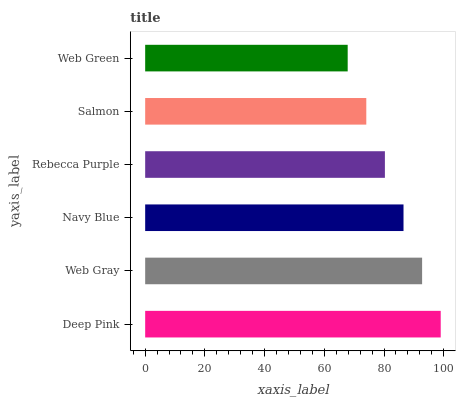Is Web Green the minimum?
Answer yes or no. Yes. Is Deep Pink the maximum?
Answer yes or no. Yes. Is Web Gray the minimum?
Answer yes or no. No. Is Web Gray the maximum?
Answer yes or no. No. Is Deep Pink greater than Web Gray?
Answer yes or no. Yes. Is Web Gray less than Deep Pink?
Answer yes or no. Yes. Is Web Gray greater than Deep Pink?
Answer yes or no. No. Is Deep Pink less than Web Gray?
Answer yes or no. No. Is Navy Blue the high median?
Answer yes or no. Yes. Is Rebecca Purple the low median?
Answer yes or no. Yes. Is Deep Pink the high median?
Answer yes or no. No. Is Web Green the low median?
Answer yes or no. No. 